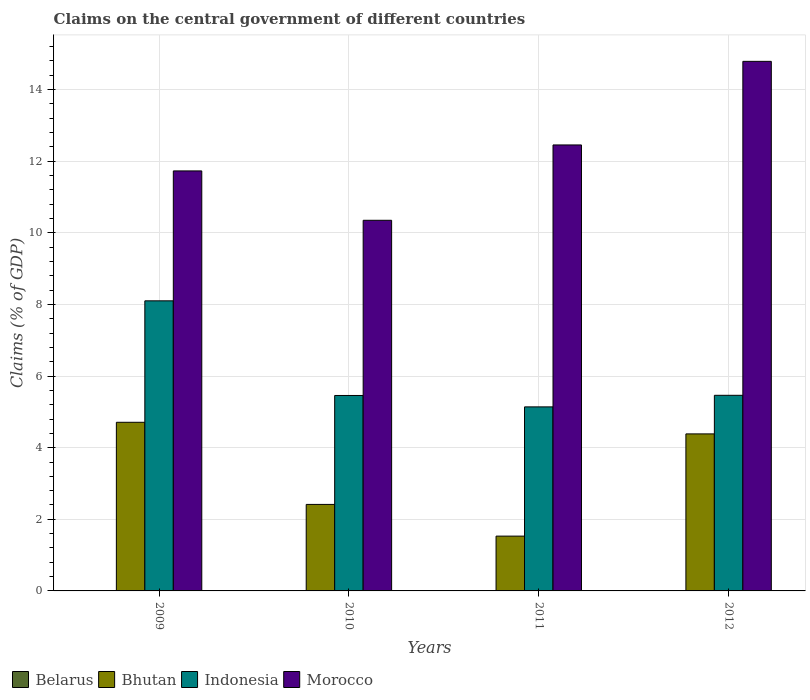How many different coloured bars are there?
Your response must be concise. 3. Are the number of bars per tick equal to the number of legend labels?
Keep it short and to the point. No. Are the number of bars on each tick of the X-axis equal?
Your response must be concise. Yes. How many bars are there on the 1st tick from the left?
Keep it short and to the point. 3. How many bars are there on the 4th tick from the right?
Your answer should be compact. 3. In how many cases, is the number of bars for a given year not equal to the number of legend labels?
Your response must be concise. 4. What is the percentage of GDP claimed on the central government in Bhutan in 2012?
Your answer should be very brief. 4.39. Across all years, what is the maximum percentage of GDP claimed on the central government in Indonesia?
Keep it short and to the point. 8.1. Across all years, what is the minimum percentage of GDP claimed on the central government in Belarus?
Provide a succinct answer. 0. In which year was the percentage of GDP claimed on the central government in Bhutan maximum?
Your answer should be very brief. 2009. What is the total percentage of GDP claimed on the central government in Morocco in the graph?
Keep it short and to the point. 49.33. What is the difference between the percentage of GDP claimed on the central government in Indonesia in 2009 and that in 2012?
Keep it short and to the point. 2.64. What is the difference between the percentage of GDP claimed on the central government in Belarus in 2011 and the percentage of GDP claimed on the central government in Indonesia in 2010?
Your response must be concise. -5.46. What is the average percentage of GDP claimed on the central government in Morocco per year?
Keep it short and to the point. 12.33. In the year 2009, what is the difference between the percentage of GDP claimed on the central government in Morocco and percentage of GDP claimed on the central government in Bhutan?
Your answer should be very brief. 7.02. What is the ratio of the percentage of GDP claimed on the central government in Indonesia in 2010 to that in 2012?
Your answer should be compact. 1. What is the difference between the highest and the second highest percentage of GDP claimed on the central government in Morocco?
Keep it short and to the point. 2.33. What is the difference between the highest and the lowest percentage of GDP claimed on the central government in Bhutan?
Provide a succinct answer. 3.18. In how many years, is the percentage of GDP claimed on the central government in Morocco greater than the average percentage of GDP claimed on the central government in Morocco taken over all years?
Offer a terse response. 2. Is it the case that in every year, the sum of the percentage of GDP claimed on the central government in Morocco and percentage of GDP claimed on the central government in Indonesia is greater than the sum of percentage of GDP claimed on the central government in Belarus and percentage of GDP claimed on the central government in Bhutan?
Provide a short and direct response. Yes. Is it the case that in every year, the sum of the percentage of GDP claimed on the central government in Belarus and percentage of GDP claimed on the central government in Indonesia is greater than the percentage of GDP claimed on the central government in Morocco?
Provide a succinct answer. No. Are all the bars in the graph horizontal?
Your answer should be very brief. No. What is the difference between two consecutive major ticks on the Y-axis?
Give a very brief answer. 2. Are the values on the major ticks of Y-axis written in scientific E-notation?
Your response must be concise. No. Does the graph contain any zero values?
Ensure brevity in your answer.  Yes. Where does the legend appear in the graph?
Keep it short and to the point. Bottom left. How many legend labels are there?
Offer a terse response. 4. How are the legend labels stacked?
Your answer should be compact. Horizontal. What is the title of the graph?
Keep it short and to the point. Claims on the central government of different countries. Does "Fragile and conflict affected situations" appear as one of the legend labels in the graph?
Your answer should be compact. No. What is the label or title of the Y-axis?
Keep it short and to the point. Claims (% of GDP). What is the Claims (% of GDP) in Belarus in 2009?
Offer a terse response. 0. What is the Claims (% of GDP) in Bhutan in 2009?
Provide a succinct answer. 4.71. What is the Claims (% of GDP) in Indonesia in 2009?
Offer a terse response. 8.1. What is the Claims (% of GDP) in Morocco in 2009?
Your response must be concise. 11.73. What is the Claims (% of GDP) of Bhutan in 2010?
Provide a short and direct response. 2.42. What is the Claims (% of GDP) in Indonesia in 2010?
Give a very brief answer. 5.46. What is the Claims (% of GDP) of Morocco in 2010?
Offer a very short reply. 10.35. What is the Claims (% of GDP) of Belarus in 2011?
Ensure brevity in your answer.  0. What is the Claims (% of GDP) of Bhutan in 2011?
Keep it short and to the point. 1.53. What is the Claims (% of GDP) of Indonesia in 2011?
Make the answer very short. 5.14. What is the Claims (% of GDP) of Morocco in 2011?
Your answer should be very brief. 12.46. What is the Claims (% of GDP) in Belarus in 2012?
Your answer should be very brief. 0. What is the Claims (% of GDP) in Bhutan in 2012?
Make the answer very short. 4.39. What is the Claims (% of GDP) in Indonesia in 2012?
Provide a succinct answer. 5.46. What is the Claims (% of GDP) of Morocco in 2012?
Your response must be concise. 14.79. Across all years, what is the maximum Claims (% of GDP) of Bhutan?
Your answer should be very brief. 4.71. Across all years, what is the maximum Claims (% of GDP) of Indonesia?
Give a very brief answer. 8.1. Across all years, what is the maximum Claims (% of GDP) of Morocco?
Make the answer very short. 14.79. Across all years, what is the minimum Claims (% of GDP) of Bhutan?
Offer a very short reply. 1.53. Across all years, what is the minimum Claims (% of GDP) of Indonesia?
Offer a terse response. 5.14. Across all years, what is the minimum Claims (% of GDP) in Morocco?
Give a very brief answer. 10.35. What is the total Claims (% of GDP) in Belarus in the graph?
Provide a succinct answer. 0. What is the total Claims (% of GDP) in Bhutan in the graph?
Keep it short and to the point. 13.04. What is the total Claims (% of GDP) in Indonesia in the graph?
Your answer should be very brief. 24.16. What is the total Claims (% of GDP) in Morocco in the graph?
Your answer should be very brief. 49.33. What is the difference between the Claims (% of GDP) of Bhutan in 2009 and that in 2010?
Keep it short and to the point. 2.29. What is the difference between the Claims (% of GDP) of Indonesia in 2009 and that in 2010?
Offer a terse response. 2.64. What is the difference between the Claims (% of GDP) in Morocco in 2009 and that in 2010?
Offer a terse response. 1.38. What is the difference between the Claims (% of GDP) in Bhutan in 2009 and that in 2011?
Offer a terse response. 3.18. What is the difference between the Claims (% of GDP) of Indonesia in 2009 and that in 2011?
Offer a terse response. 2.96. What is the difference between the Claims (% of GDP) of Morocco in 2009 and that in 2011?
Make the answer very short. -0.73. What is the difference between the Claims (% of GDP) in Bhutan in 2009 and that in 2012?
Your answer should be compact. 0.32. What is the difference between the Claims (% of GDP) in Indonesia in 2009 and that in 2012?
Make the answer very short. 2.64. What is the difference between the Claims (% of GDP) in Morocco in 2009 and that in 2012?
Offer a terse response. -3.06. What is the difference between the Claims (% of GDP) of Bhutan in 2010 and that in 2011?
Make the answer very short. 0.89. What is the difference between the Claims (% of GDP) of Indonesia in 2010 and that in 2011?
Your answer should be compact. 0.32. What is the difference between the Claims (% of GDP) of Morocco in 2010 and that in 2011?
Your answer should be very brief. -2.1. What is the difference between the Claims (% of GDP) of Bhutan in 2010 and that in 2012?
Offer a very short reply. -1.97. What is the difference between the Claims (% of GDP) in Indonesia in 2010 and that in 2012?
Provide a short and direct response. -0. What is the difference between the Claims (% of GDP) of Morocco in 2010 and that in 2012?
Provide a succinct answer. -4.44. What is the difference between the Claims (% of GDP) in Bhutan in 2011 and that in 2012?
Your answer should be compact. -2.85. What is the difference between the Claims (% of GDP) in Indonesia in 2011 and that in 2012?
Offer a terse response. -0.32. What is the difference between the Claims (% of GDP) of Morocco in 2011 and that in 2012?
Offer a very short reply. -2.33. What is the difference between the Claims (% of GDP) of Bhutan in 2009 and the Claims (% of GDP) of Indonesia in 2010?
Give a very brief answer. -0.75. What is the difference between the Claims (% of GDP) of Bhutan in 2009 and the Claims (% of GDP) of Morocco in 2010?
Provide a succinct answer. -5.64. What is the difference between the Claims (% of GDP) in Indonesia in 2009 and the Claims (% of GDP) in Morocco in 2010?
Your answer should be very brief. -2.25. What is the difference between the Claims (% of GDP) in Bhutan in 2009 and the Claims (% of GDP) in Indonesia in 2011?
Give a very brief answer. -0.43. What is the difference between the Claims (% of GDP) in Bhutan in 2009 and the Claims (% of GDP) in Morocco in 2011?
Provide a short and direct response. -7.75. What is the difference between the Claims (% of GDP) in Indonesia in 2009 and the Claims (% of GDP) in Morocco in 2011?
Provide a short and direct response. -4.35. What is the difference between the Claims (% of GDP) in Bhutan in 2009 and the Claims (% of GDP) in Indonesia in 2012?
Give a very brief answer. -0.75. What is the difference between the Claims (% of GDP) in Bhutan in 2009 and the Claims (% of GDP) in Morocco in 2012?
Your answer should be compact. -10.08. What is the difference between the Claims (% of GDP) in Indonesia in 2009 and the Claims (% of GDP) in Morocco in 2012?
Offer a terse response. -6.69. What is the difference between the Claims (% of GDP) of Bhutan in 2010 and the Claims (% of GDP) of Indonesia in 2011?
Provide a succinct answer. -2.72. What is the difference between the Claims (% of GDP) of Bhutan in 2010 and the Claims (% of GDP) of Morocco in 2011?
Your response must be concise. -10.04. What is the difference between the Claims (% of GDP) in Indonesia in 2010 and the Claims (% of GDP) in Morocco in 2011?
Provide a succinct answer. -7. What is the difference between the Claims (% of GDP) in Bhutan in 2010 and the Claims (% of GDP) in Indonesia in 2012?
Make the answer very short. -3.05. What is the difference between the Claims (% of GDP) in Bhutan in 2010 and the Claims (% of GDP) in Morocco in 2012?
Your answer should be compact. -12.37. What is the difference between the Claims (% of GDP) in Indonesia in 2010 and the Claims (% of GDP) in Morocco in 2012?
Your answer should be compact. -9.33. What is the difference between the Claims (% of GDP) of Bhutan in 2011 and the Claims (% of GDP) of Indonesia in 2012?
Your answer should be very brief. -3.93. What is the difference between the Claims (% of GDP) in Bhutan in 2011 and the Claims (% of GDP) in Morocco in 2012?
Ensure brevity in your answer.  -13.26. What is the difference between the Claims (% of GDP) of Indonesia in 2011 and the Claims (% of GDP) of Morocco in 2012?
Keep it short and to the point. -9.65. What is the average Claims (% of GDP) of Bhutan per year?
Ensure brevity in your answer.  3.26. What is the average Claims (% of GDP) of Indonesia per year?
Provide a short and direct response. 6.04. What is the average Claims (% of GDP) of Morocco per year?
Keep it short and to the point. 12.33. In the year 2009, what is the difference between the Claims (% of GDP) in Bhutan and Claims (% of GDP) in Indonesia?
Your answer should be compact. -3.39. In the year 2009, what is the difference between the Claims (% of GDP) of Bhutan and Claims (% of GDP) of Morocco?
Your answer should be compact. -7.02. In the year 2009, what is the difference between the Claims (% of GDP) of Indonesia and Claims (% of GDP) of Morocco?
Offer a terse response. -3.63. In the year 2010, what is the difference between the Claims (% of GDP) of Bhutan and Claims (% of GDP) of Indonesia?
Your answer should be compact. -3.04. In the year 2010, what is the difference between the Claims (% of GDP) of Bhutan and Claims (% of GDP) of Morocco?
Your answer should be very brief. -7.94. In the year 2010, what is the difference between the Claims (% of GDP) of Indonesia and Claims (% of GDP) of Morocco?
Make the answer very short. -4.89. In the year 2011, what is the difference between the Claims (% of GDP) in Bhutan and Claims (% of GDP) in Indonesia?
Your answer should be very brief. -3.61. In the year 2011, what is the difference between the Claims (% of GDP) in Bhutan and Claims (% of GDP) in Morocco?
Your answer should be compact. -10.92. In the year 2011, what is the difference between the Claims (% of GDP) of Indonesia and Claims (% of GDP) of Morocco?
Give a very brief answer. -7.32. In the year 2012, what is the difference between the Claims (% of GDP) of Bhutan and Claims (% of GDP) of Indonesia?
Make the answer very short. -1.08. In the year 2012, what is the difference between the Claims (% of GDP) of Bhutan and Claims (% of GDP) of Morocco?
Provide a short and direct response. -10.4. In the year 2012, what is the difference between the Claims (% of GDP) in Indonesia and Claims (% of GDP) in Morocco?
Offer a terse response. -9.33. What is the ratio of the Claims (% of GDP) in Bhutan in 2009 to that in 2010?
Your response must be concise. 1.95. What is the ratio of the Claims (% of GDP) in Indonesia in 2009 to that in 2010?
Ensure brevity in your answer.  1.48. What is the ratio of the Claims (% of GDP) in Morocco in 2009 to that in 2010?
Provide a succinct answer. 1.13. What is the ratio of the Claims (% of GDP) in Bhutan in 2009 to that in 2011?
Ensure brevity in your answer.  3.08. What is the ratio of the Claims (% of GDP) of Indonesia in 2009 to that in 2011?
Your answer should be compact. 1.58. What is the ratio of the Claims (% of GDP) in Morocco in 2009 to that in 2011?
Give a very brief answer. 0.94. What is the ratio of the Claims (% of GDP) of Bhutan in 2009 to that in 2012?
Give a very brief answer. 1.07. What is the ratio of the Claims (% of GDP) in Indonesia in 2009 to that in 2012?
Your response must be concise. 1.48. What is the ratio of the Claims (% of GDP) in Morocco in 2009 to that in 2012?
Offer a terse response. 0.79. What is the ratio of the Claims (% of GDP) in Bhutan in 2010 to that in 2011?
Provide a succinct answer. 1.58. What is the ratio of the Claims (% of GDP) of Indonesia in 2010 to that in 2011?
Ensure brevity in your answer.  1.06. What is the ratio of the Claims (% of GDP) in Morocco in 2010 to that in 2011?
Give a very brief answer. 0.83. What is the ratio of the Claims (% of GDP) of Bhutan in 2010 to that in 2012?
Provide a succinct answer. 0.55. What is the ratio of the Claims (% of GDP) in Indonesia in 2010 to that in 2012?
Ensure brevity in your answer.  1. What is the ratio of the Claims (% of GDP) of Morocco in 2010 to that in 2012?
Ensure brevity in your answer.  0.7. What is the ratio of the Claims (% of GDP) in Bhutan in 2011 to that in 2012?
Keep it short and to the point. 0.35. What is the ratio of the Claims (% of GDP) in Indonesia in 2011 to that in 2012?
Keep it short and to the point. 0.94. What is the ratio of the Claims (% of GDP) in Morocco in 2011 to that in 2012?
Your answer should be very brief. 0.84. What is the difference between the highest and the second highest Claims (% of GDP) of Bhutan?
Ensure brevity in your answer.  0.32. What is the difference between the highest and the second highest Claims (% of GDP) of Indonesia?
Your answer should be very brief. 2.64. What is the difference between the highest and the second highest Claims (% of GDP) in Morocco?
Your answer should be compact. 2.33. What is the difference between the highest and the lowest Claims (% of GDP) of Bhutan?
Keep it short and to the point. 3.18. What is the difference between the highest and the lowest Claims (% of GDP) of Indonesia?
Offer a terse response. 2.96. What is the difference between the highest and the lowest Claims (% of GDP) in Morocco?
Provide a succinct answer. 4.44. 